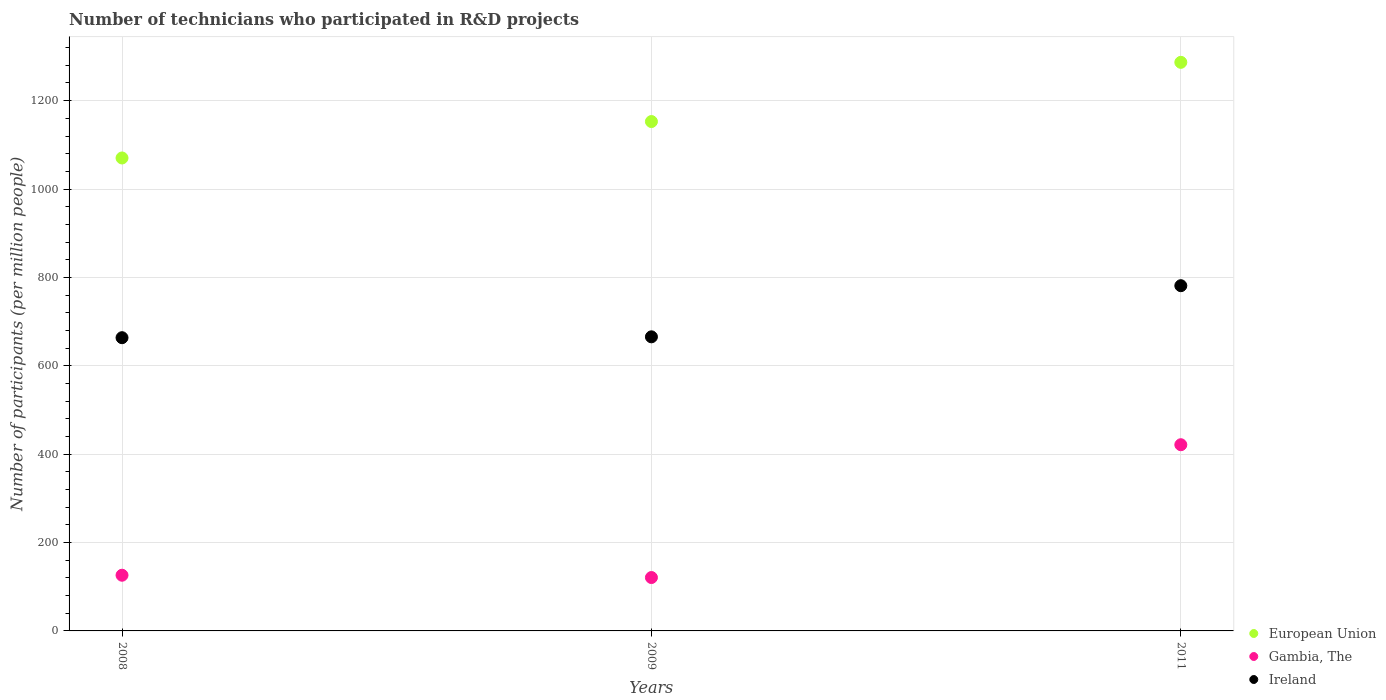How many different coloured dotlines are there?
Provide a succinct answer. 3. What is the number of technicians who participated in R&D projects in European Union in 2011?
Ensure brevity in your answer.  1286.74. Across all years, what is the maximum number of technicians who participated in R&D projects in Gambia, The?
Make the answer very short. 421.36. Across all years, what is the minimum number of technicians who participated in R&D projects in Ireland?
Your response must be concise. 663.59. What is the total number of technicians who participated in R&D projects in European Union in the graph?
Ensure brevity in your answer.  3509.78. What is the difference between the number of technicians who participated in R&D projects in European Union in 2008 and that in 2009?
Offer a terse response. -82.43. What is the difference between the number of technicians who participated in R&D projects in Gambia, The in 2009 and the number of technicians who participated in R&D projects in European Union in 2008?
Provide a short and direct response. -949.49. What is the average number of technicians who participated in R&D projects in European Union per year?
Offer a very short reply. 1169.93. In the year 2011, what is the difference between the number of technicians who participated in R&D projects in European Union and number of technicians who participated in R&D projects in Gambia, The?
Provide a succinct answer. 865.39. What is the ratio of the number of technicians who participated in R&D projects in Gambia, The in 2008 to that in 2011?
Keep it short and to the point. 0.3. Is the number of technicians who participated in R&D projects in Gambia, The in 2008 less than that in 2009?
Provide a succinct answer. No. Is the difference between the number of technicians who participated in R&D projects in European Union in 2008 and 2011 greater than the difference between the number of technicians who participated in R&D projects in Gambia, The in 2008 and 2011?
Provide a short and direct response. Yes. What is the difference between the highest and the second highest number of technicians who participated in R&D projects in Gambia, The?
Your answer should be very brief. 295.32. What is the difference between the highest and the lowest number of technicians who participated in R&D projects in European Union?
Provide a short and direct response. 216.44. In how many years, is the number of technicians who participated in R&D projects in European Union greater than the average number of technicians who participated in R&D projects in European Union taken over all years?
Provide a short and direct response. 1. Is the sum of the number of technicians who participated in R&D projects in Ireland in 2009 and 2011 greater than the maximum number of technicians who participated in R&D projects in Gambia, The across all years?
Your answer should be compact. Yes. Is the number of technicians who participated in R&D projects in Ireland strictly greater than the number of technicians who participated in R&D projects in European Union over the years?
Offer a terse response. No. Is the number of technicians who participated in R&D projects in European Union strictly less than the number of technicians who participated in R&D projects in Ireland over the years?
Your answer should be very brief. No. How many years are there in the graph?
Offer a very short reply. 3. Are the values on the major ticks of Y-axis written in scientific E-notation?
Give a very brief answer. No. How many legend labels are there?
Provide a succinct answer. 3. How are the legend labels stacked?
Provide a short and direct response. Vertical. What is the title of the graph?
Give a very brief answer. Number of technicians who participated in R&D projects. What is the label or title of the Y-axis?
Offer a very short reply. Number of participants (per million people). What is the Number of participants (per million people) of European Union in 2008?
Offer a terse response. 1070.3. What is the Number of participants (per million people) of Gambia, The in 2008?
Ensure brevity in your answer.  126.04. What is the Number of participants (per million people) of Ireland in 2008?
Ensure brevity in your answer.  663.59. What is the Number of participants (per million people) in European Union in 2009?
Offer a very short reply. 1152.73. What is the Number of participants (per million people) in Gambia, The in 2009?
Provide a short and direct response. 120.81. What is the Number of participants (per million people) in Ireland in 2009?
Give a very brief answer. 665.55. What is the Number of participants (per million people) of European Union in 2011?
Provide a short and direct response. 1286.74. What is the Number of participants (per million people) in Gambia, The in 2011?
Offer a terse response. 421.36. What is the Number of participants (per million people) of Ireland in 2011?
Make the answer very short. 781.26. Across all years, what is the maximum Number of participants (per million people) in European Union?
Keep it short and to the point. 1286.74. Across all years, what is the maximum Number of participants (per million people) of Gambia, The?
Your response must be concise. 421.36. Across all years, what is the maximum Number of participants (per million people) of Ireland?
Keep it short and to the point. 781.26. Across all years, what is the minimum Number of participants (per million people) of European Union?
Ensure brevity in your answer.  1070.3. Across all years, what is the minimum Number of participants (per million people) of Gambia, The?
Give a very brief answer. 120.81. Across all years, what is the minimum Number of participants (per million people) in Ireland?
Offer a terse response. 663.59. What is the total Number of participants (per million people) of European Union in the graph?
Your answer should be very brief. 3509.78. What is the total Number of participants (per million people) in Gambia, The in the graph?
Keep it short and to the point. 668.22. What is the total Number of participants (per million people) of Ireland in the graph?
Provide a succinct answer. 2110.41. What is the difference between the Number of participants (per million people) of European Union in 2008 and that in 2009?
Provide a succinct answer. -82.43. What is the difference between the Number of participants (per million people) in Gambia, The in 2008 and that in 2009?
Ensure brevity in your answer.  5.23. What is the difference between the Number of participants (per million people) of Ireland in 2008 and that in 2009?
Offer a very short reply. -1.96. What is the difference between the Number of participants (per million people) of European Union in 2008 and that in 2011?
Make the answer very short. -216.44. What is the difference between the Number of participants (per million people) in Gambia, The in 2008 and that in 2011?
Offer a terse response. -295.32. What is the difference between the Number of participants (per million people) in Ireland in 2008 and that in 2011?
Offer a terse response. -117.67. What is the difference between the Number of participants (per million people) in European Union in 2009 and that in 2011?
Ensure brevity in your answer.  -134.01. What is the difference between the Number of participants (per million people) in Gambia, The in 2009 and that in 2011?
Ensure brevity in your answer.  -300.55. What is the difference between the Number of participants (per million people) in Ireland in 2009 and that in 2011?
Provide a short and direct response. -115.71. What is the difference between the Number of participants (per million people) of European Union in 2008 and the Number of participants (per million people) of Gambia, The in 2009?
Provide a short and direct response. 949.49. What is the difference between the Number of participants (per million people) in European Union in 2008 and the Number of participants (per million people) in Ireland in 2009?
Your response must be concise. 404.75. What is the difference between the Number of participants (per million people) of Gambia, The in 2008 and the Number of participants (per million people) of Ireland in 2009?
Keep it short and to the point. -539.51. What is the difference between the Number of participants (per million people) of European Union in 2008 and the Number of participants (per million people) of Gambia, The in 2011?
Make the answer very short. 648.94. What is the difference between the Number of participants (per million people) in European Union in 2008 and the Number of participants (per million people) in Ireland in 2011?
Your answer should be compact. 289.04. What is the difference between the Number of participants (per million people) in Gambia, The in 2008 and the Number of participants (per million people) in Ireland in 2011?
Keep it short and to the point. -655.22. What is the difference between the Number of participants (per million people) in European Union in 2009 and the Number of participants (per million people) in Gambia, The in 2011?
Keep it short and to the point. 731.37. What is the difference between the Number of participants (per million people) of European Union in 2009 and the Number of participants (per million people) of Ireland in 2011?
Your answer should be very brief. 371.47. What is the difference between the Number of participants (per million people) in Gambia, The in 2009 and the Number of participants (per million people) in Ireland in 2011?
Provide a short and direct response. -660.45. What is the average Number of participants (per million people) of European Union per year?
Provide a short and direct response. 1169.93. What is the average Number of participants (per million people) in Gambia, The per year?
Your response must be concise. 222.74. What is the average Number of participants (per million people) in Ireland per year?
Your answer should be compact. 703.47. In the year 2008, what is the difference between the Number of participants (per million people) in European Union and Number of participants (per million people) in Gambia, The?
Offer a very short reply. 944.26. In the year 2008, what is the difference between the Number of participants (per million people) in European Union and Number of participants (per million people) in Ireland?
Keep it short and to the point. 406.71. In the year 2008, what is the difference between the Number of participants (per million people) in Gambia, The and Number of participants (per million people) in Ireland?
Your response must be concise. -537.55. In the year 2009, what is the difference between the Number of participants (per million people) of European Union and Number of participants (per million people) of Gambia, The?
Offer a very short reply. 1031.92. In the year 2009, what is the difference between the Number of participants (per million people) in European Union and Number of participants (per million people) in Ireland?
Provide a succinct answer. 487.18. In the year 2009, what is the difference between the Number of participants (per million people) in Gambia, The and Number of participants (per million people) in Ireland?
Offer a terse response. -544.74. In the year 2011, what is the difference between the Number of participants (per million people) in European Union and Number of participants (per million people) in Gambia, The?
Make the answer very short. 865.39. In the year 2011, what is the difference between the Number of participants (per million people) of European Union and Number of participants (per million people) of Ireland?
Your answer should be very brief. 505.48. In the year 2011, what is the difference between the Number of participants (per million people) in Gambia, The and Number of participants (per million people) in Ireland?
Keep it short and to the point. -359.9. What is the ratio of the Number of participants (per million people) in European Union in 2008 to that in 2009?
Make the answer very short. 0.93. What is the ratio of the Number of participants (per million people) of Gambia, The in 2008 to that in 2009?
Offer a very short reply. 1.04. What is the ratio of the Number of participants (per million people) of Ireland in 2008 to that in 2009?
Provide a succinct answer. 1. What is the ratio of the Number of participants (per million people) in European Union in 2008 to that in 2011?
Ensure brevity in your answer.  0.83. What is the ratio of the Number of participants (per million people) of Gambia, The in 2008 to that in 2011?
Your answer should be very brief. 0.3. What is the ratio of the Number of participants (per million people) in Ireland in 2008 to that in 2011?
Offer a terse response. 0.85. What is the ratio of the Number of participants (per million people) in European Union in 2009 to that in 2011?
Keep it short and to the point. 0.9. What is the ratio of the Number of participants (per million people) of Gambia, The in 2009 to that in 2011?
Offer a very short reply. 0.29. What is the ratio of the Number of participants (per million people) of Ireland in 2009 to that in 2011?
Your answer should be very brief. 0.85. What is the difference between the highest and the second highest Number of participants (per million people) in European Union?
Ensure brevity in your answer.  134.01. What is the difference between the highest and the second highest Number of participants (per million people) in Gambia, The?
Make the answer very short. 295.32. What is the difference between the highest and the second highest Number of participants (per million people) in Ireland?
Your response must be concise. 115.71. What is the difference between the highest and the lowest Number of participants (per million people) in European Union?
Ensure brevity in your answer.  216.44. What is the difference between the highest and the lowest Number of participants (per million people) in Gambia, The?
Your answer should be very brief. 300.55. What is the difference between the highest and the lowest Number of participants (per million people) in Ireland?
Make the answer very short. 117.67. 